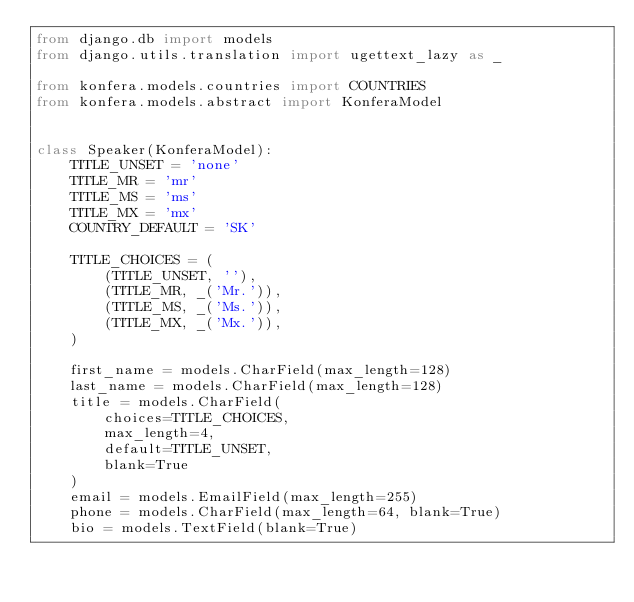<code> <loc_0><loc_0><loc_500><loc_500><_Python_>from django.db import models
from django.utils.translation import ugettext_lazy as _

from konfera.models.countries import COUNTRIES
from konfera.models.abstract import KonferaModel


class Speaker(KonferaModel):
    TITLE_UNSET = 'none'
    TITLE_MR = 'mr'
    TITLE_MS = 'ms'
    TITLE_MX = 'mx'
    COUNTRY_DEFAULT = 'SK'

    TITLE_CHOICES = (
        (TITLE_UNSET, ''),
        (TITLE_MR, _('Mr.')),
        (TITLE_MS, _('Ms.')),
        (TITLE_MX, _('Mx.')),
    )

    first_name = models.CharField(max_length=128)
    last_name = models.CharField(max_length=128)
    title = models.CharField(
        choices=TITLE_CHOICES,
        max_length=4,
        default=TITLE_UNSET,
        blank=True
    )
    email = models.EmailField(max_length=255)
    phone = models.CharField(max_length=64, blank=True)
    bio = models.TextField(blank=True)</code> 